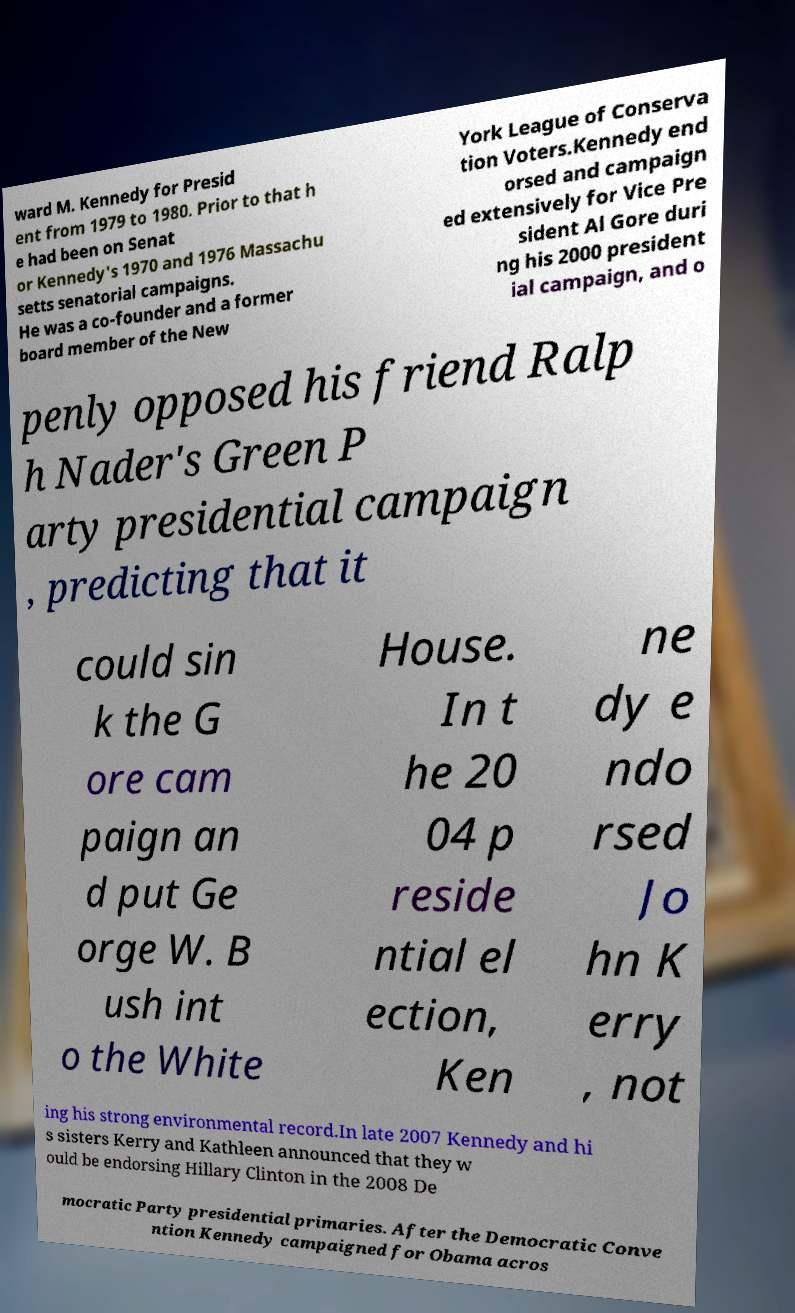Can you accurately transcribe the text from the provided image for me? ward M. Kennedy for Presid ent from 1979 to 1980. Prior to that h e had been on Senat or Kennedy's 1970 and 1976 Massachu setts senatorial campaigns. He was a co-founder and a former board member of the New York League of Conserva tion Voters.Kennedy end orsed and campaign ed extensively for Vice Pre sident Al Gore duri ng his 2000 president ial campaign, and o penly opposed his friend Ralp h Nader's Green P arty presidential campaign , predicting that it could sin k the G ore cam paign an d put Ge orge W. B ush int o the White House. In t he 20 04 p reside ntial el ection, Ken ne dy e ndo rsed Jo hn K erry , not ing his strong environmental record.In late 2007 Kennedy and hi s sisters Kerry and Kathleen announced that they w ould be endorsing Hillary Clinton in the 2008 De mocratic Party presidential primaries. After the Democratic Conve ntion Kennedy campaigned for Obama acros 